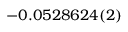Convert formula to latex. <formula><loc_0><loc_0><loc_500><loc_500>- 0 . 0 5 2 8 6 2 4 ( 2 )</formula> 